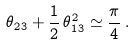<formula> <loc_0><loc_0><loc_500><loc_500>\theta _ { 2 3 } + \frac { 1 } { 2 } \, \theta _ { 1 3 } ^ { 2 } \simeq \frac { \pi } { 4 } \, .</formula> 